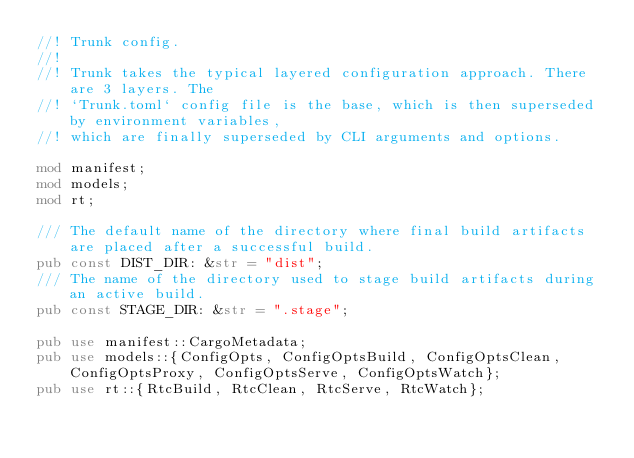Convert code to text. <code><loc_0><loc_0><loc_500><loc_500><_Rust_>//! Trunk config.
//!
//! Trunk takes the typical layered configuration approach. There are 3 layers. The
//! `Trunk.toml` config file is the base, which is then superseded by environment variables,
//! which are finally superseded by CLI arguments and options.

mod manifest;
mod models;
mod rt;

/// The default name of the directory where final build artifacts are placed after a successful build.
pub const DIST_DIR: &str = "dist";
/// The name of the directory used to stage build artifacts during an active build.
pub const STAGE_DIR: &str = ".stage";

pub use manifest::CargoMetadata;
pub use models::{ConfigOpts, ConfigOptsBuild, ConfigOptsClean, ConfigOptsProxy, ConfigOptsServe, ConfigOptsWatch};
pub use rt::{RtcBuild, RtcClean, RtcServe, RtcWatch};
</code> 